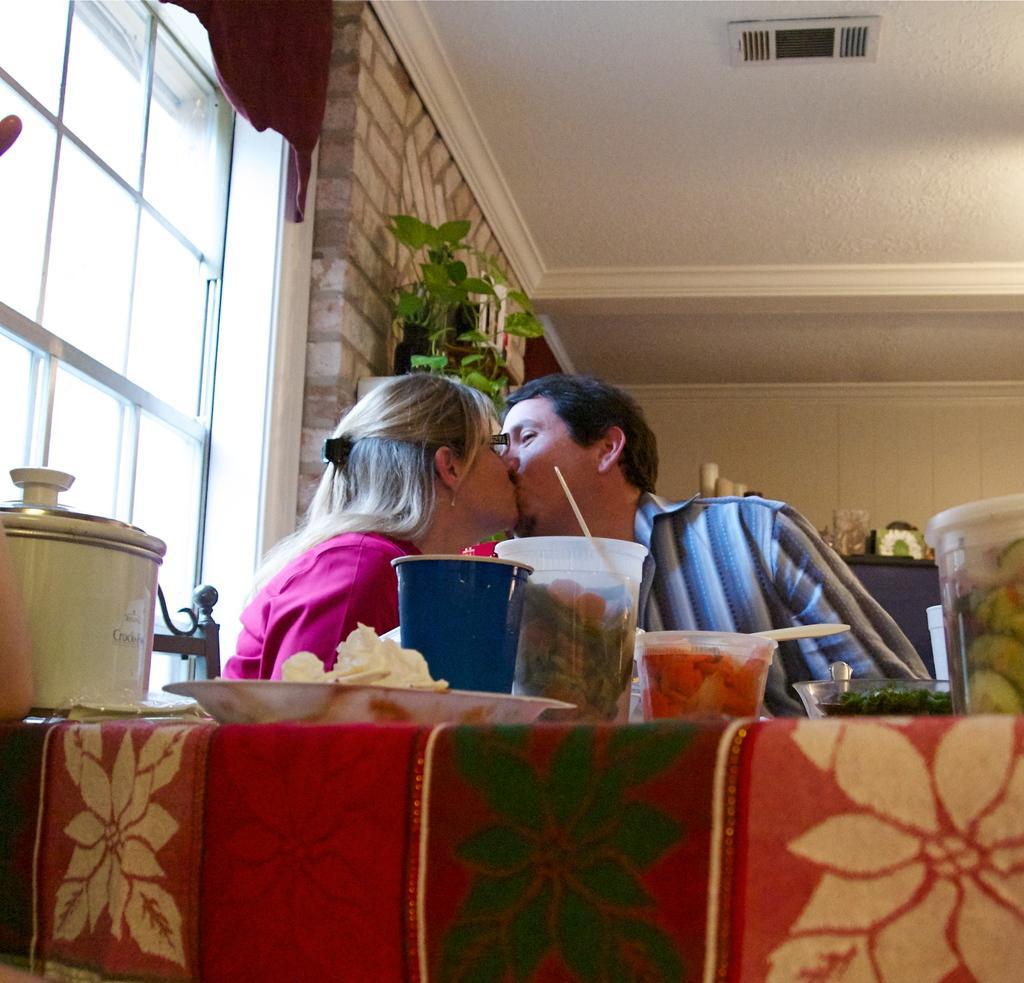In one or two sentences, can you explain what this image depicts? In this image we can see two persons. One woman is wearing spectacles and a pink dress. In the foreground we can see group of glasses, containers and plates are placed on the table. In the background, we can see a plant, window and curtain. 